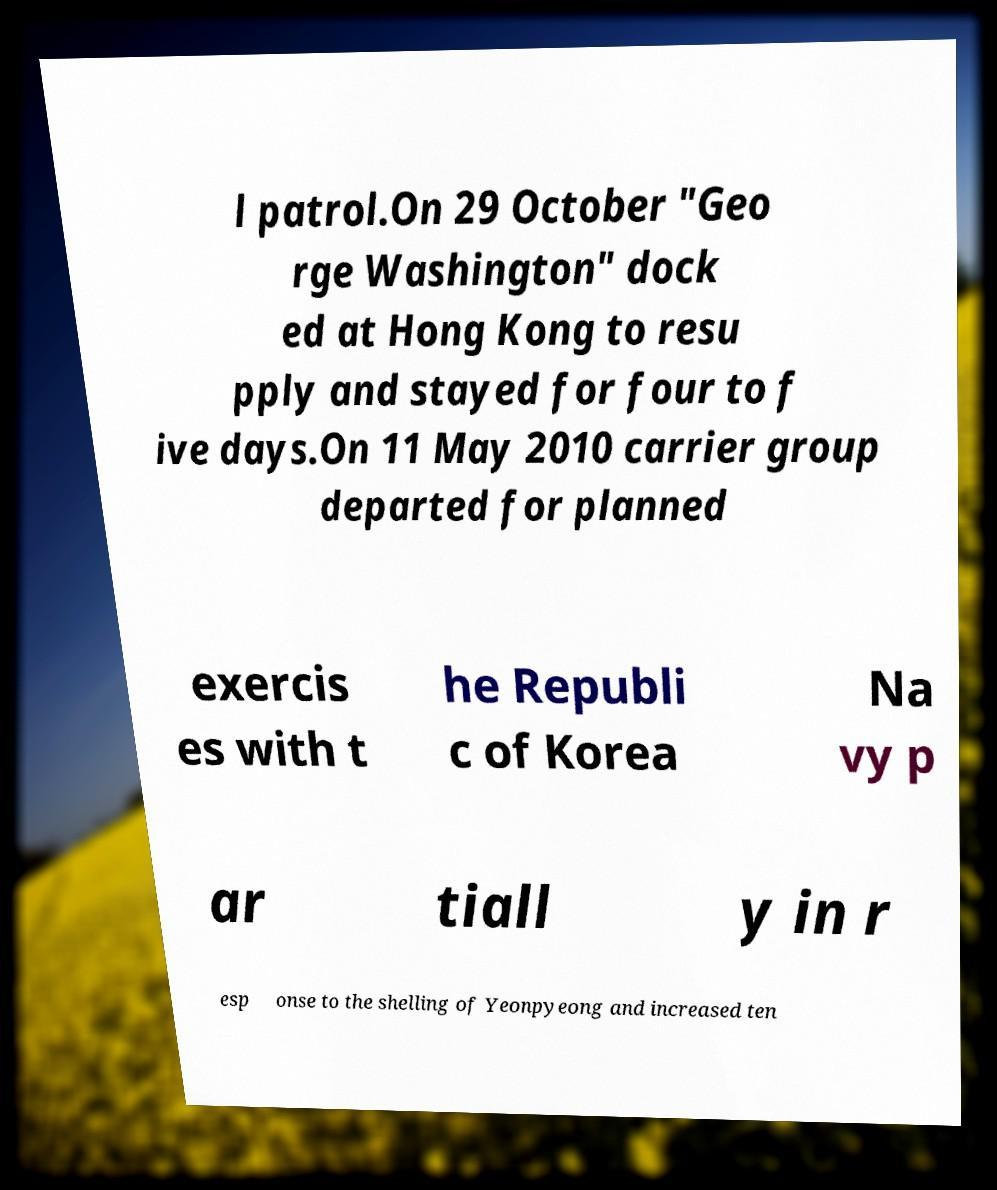Could you extract and type out the text from this image? l patrol.On 29 October "Geo rge Washington" dock ed at Hong Kong to resu pply and stayed for four to f ive days.On 11 May 2010 carrier group departed for planned exercis es with t he Republi c of Korea Na vy p ar tiall y in r esp onse to the shelling of Yeonpyeong and increased ten 